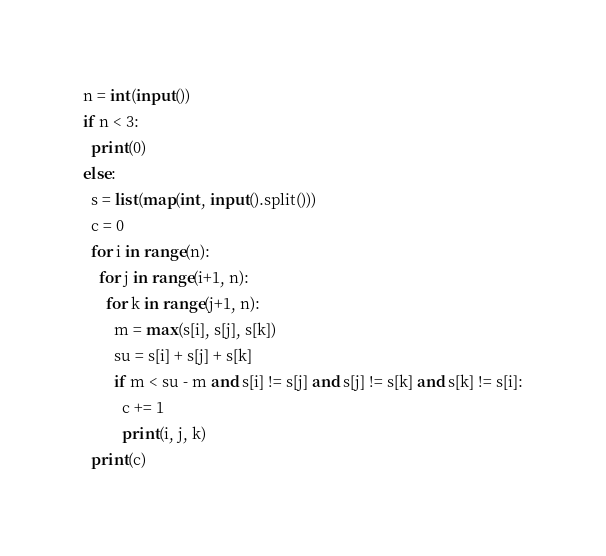Convert code to text. <code><loc_0><loc_0><loc_500><loc_500><_Python_>n = int(input())
if n < 3:
  print(0)
else:
  s = list(map(int, input().split()))
  c = 0
  for i in range(n):
    for j in range(i+1, n):
      for k in range(j+1, n):
        m = max(s[i], s[j], s[k])
        su = s[i] + s[j] + s[k]
        if m < su - m and s[i] != s[j] and s[j] != s[k] and s[k] != s[i]:
          c += 1
          print(i, j, k)
  print(c)</code> 